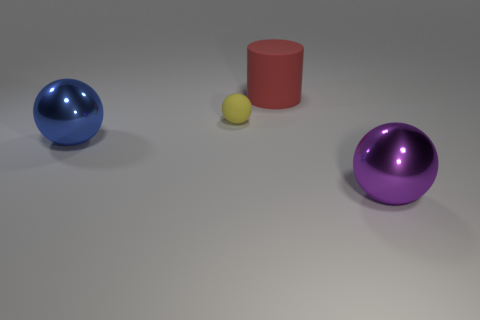Add 4 yellow things. How many objects exist? 8 Subtract all spheres. How many objects are left? 1 Subtract 1 red cylinders. How many objects are left? 3 Subtract all big purple rubber spheres. Subtract all matte things. How many objects are left? 2 Add 3 yellow rubber things. How many yellow rubber things are left? 4 Add 1 metal objects. How many metal objects exist? 3 